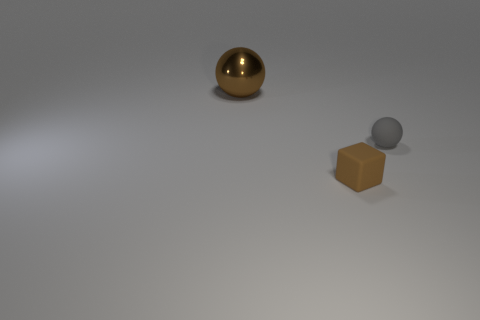Do the metal thing and the brown object on the right side of the brown metallic sphere have the same size?
Provide a succinct answer. No. What size is the other metallic object that is the same shape as the tiny gray thing?
Your answer should be very brief. Large. Is the size of the sphere that is to the right of the brown metal sphere the same as the matte cube?
Give a very brief answer. Yes. There is a matte block that is the same size as the gray object; what color is it?
Offer a very short reply. Brown. Is there a rubber thing that is to the left of the tiny thing to the right of the tiny rubber thing in front of the gray sphere?
Offer a terse response. Yes. There is a ball right of the large brown shiny sphere; what is its material?
Make the answer very short. Rubber. There is a small brown thing; is its shape the same as the thing behind the gray rubber thing?
Provide a succinct answer. No. Are there an equal number of large metallic spheres in front of the metallic sphere and blocks that are behind the gray rubber object?
Your answer should be compact. Yes. What number of other objects are there of the same material as the gray sphere?
Ensure brevity in your answer.  1. What number of rubber objects are brown cylinders or gray objects?
Offer a very short reply. 1. 